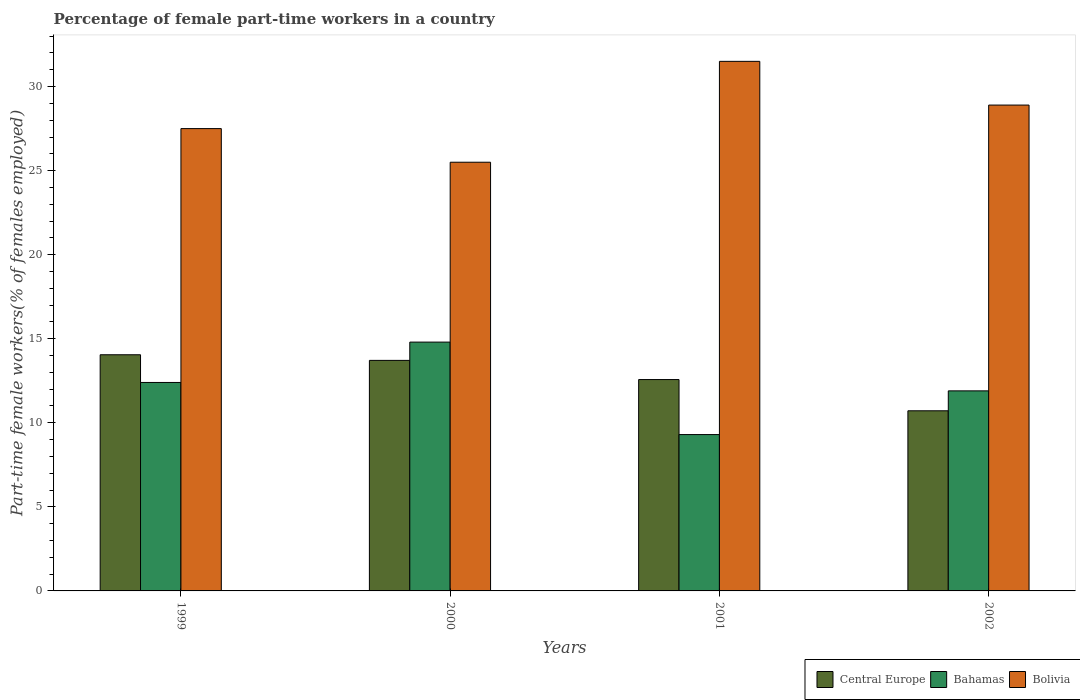How many groups of bars are there?
Make the answer very short. 4. Are the number of bars per tick equal to the number of legend labels?
Keep it short and to the point. Yes. How many bars are there on the 2nd tick from the left?
Your answer should be very brief. 3. How many bars are there on the 1st tick from the right?
Keep it short and to the point. 3. What is the label of the 2nd group of bars from the left?
Your answer should be very brief. 2000. In how many cases, is the number of bars for a given year not equal to the number of legend labels?
Ensure brevity in your answer.  0. Across all years, what is the maximum percentage of female part-time workers in Bolivia?
Your response must be concise. 31.5. Across all years, what is the minimum percentage of female part-time workers in Bahamas?
Provide a short and direct response. 9.3. What is the total percentage of female part-time workers in Bahamas in the graph?
Provide a succinct answer. 48.4. What is the difference between the percentage of female part-time workers in Central Europe in 2001 and that in 2002?
Provide a succinct answer. 1.86. What is the difference between the percentage of female part-time workers in Central Europe in 2002 and the percentage of female part-time workers in Bolivia in 1999?
Ensure brevity in your answer.  -16.79. What is the average percentage of female part-time workers in Central Europe per year?
Your answer should be very brief. 12.76. In the year 2002, what is the difference between the percentage of female part-time workers in Central Europe and percentage of female part-time workers in Bahamas?
Make the answer very short. -1.19. In how many years, is the percentage of female part-time workers in Bahamas greater than 7 %?
Your answer should be compact. 4. What is the ratio of the percentage of female part-time workers in Bahamas in 2000 to that in 2002?
Your response must be concise. 1.24. What is the difference between the highest and the second highest percentage of female part-time workers in Bolivia?
Give a very brief answer. 2.6. What is the difference between the highest and the lowest percentage of female part-time workers in Central Europe?
Your response must be concise. 3.33. Is the sum of the percentage of female part-time workers in Bahamas in 1999 and 2000 greater than the maximum percentage of female part-time workers in Central Europe across all years?
Offer a very short reply. Yes. What does the 2nd bar from the left in 2000 represents?
Provide a succinct answer. Bahamas. What does the 2nd bar from the right in 2001 represents?
Offer a terse response. Bahamas. Is it the case that in every year, the sum of the percentage of female part-time workers in Central Europe and percentage of female part-time workers in Bolivia is greater than the percentage of female part-time workers in Bahamas?
Make the answer very short. Yes. Are all the bars in the graph horizontal?
Provide a short and direct response. No. What is the difference between two consecutive major ticks on the Y-axis?
Keep it short and to the point. 5. Are the values on the major ticks of Y-axis written in scientific E-notation?
Provide a succinct answer. No. Does the graph contain any zero values?
Your answer should be compact. No. How are the legend labels stacked?
Make the answer very short. Horizontal. What is the title of the graph?
Your answer should be very brief. Percentage of female part-time workers in a country. Does "Faeroe Islands" appear as one of the legend labels in the graph?
Keep it short and to the point. No. What is the label or title of the Y-axis?
Offer a terse response. Part-time female workers(% of females employed). What is the Part-time female workers(% of females employed) in Central Europe in 1999?
Your response must be concise. 14.05. What is the Part-time female workers(% of females employed) in Bahamas in 1999?
Your response must be concise. 12.4. What is the Part-time female workers(% of females employed) of Bolivia in 1999?
Provide a succinct answer. 27.5. What is the Part-time female workers(% of females employed) in Central Europe in 2000?
Keep it short and to the point. 13.71. What is the Part-time female workers(% of females employed) in Bahamas in 2000?
Offer a terse response. 14.8. What is the Part-time female workers(% of females employed) in Central Europe in 2001?
Provide a succinct answer. 12.57. What is the Part-time female workers(% of females employed) of Bahamas in 2001?
Offer a very short reply. 9.3. What is the Part-time female workers(% of females employed) in Bolivia in 2001?
Make the answer very short. 31.5. What is the Part-time female workers(% of females employed) in Central Europe in 2002?
Your answer should be very brief. 10.71. What is the Part-time female workers(% of females employed) in Bahamas in 2002?
Give a very brief answer. 11.9. What is the Part-time female workers(% of females employed) of Bolivia in 2002?
Provide a short and direct response. 28.9. Across all years, what is the maximum Part-time female workers(% of females employed) of Central Europe?
Make the answer very short. 14.05. Across all years, what is the maximum Part-time female workers(% of females employed) in Bahamas?
Provide a short and direct response. 14.8. Across all years, what is the maximum Part-time female workers(% of females employed) in Bolivia?
Provide a succinct answer. 31.5. Across all years, what is the minimum Part-time female workers(% of females employed) in Central Europe?
Your response must be concise. 10.71. Across all years, what is the minimum Part-time female workers(% of females employed) in Bahamas?
Provide a succinct answer. 9.3. Across all years, what is the minimum Part-time female workers(% of females employed) of Bolivia?
Provide a short and direct response. 25.5. What is the total Part-time female workers(% of females employed) in Central Europe in the graph?
Your response must be concise. 51.05. What is the total Part-time female workers(% of females employed) of Bahamas in the graph?
Provide a short and direct response. 48.4. What is the total Part-time female workers(% of females employed) of Bolivia in the graph?
Provide a succinct answer. 113.4. What is the difference between the Part-time female workers(% of females employed) of Central Europe in 1999 and that in 2000?
Make the answer very short. 0.33. What is the difference between the Part-time female workers(% of females employed) in Bolivia in 1999 and that in 2000?
Your response must be concise. 2. What is the difference between the Part-time female workers(% of females employed) of Central Europe in 1999 and that in 2001?
Your answer should be very brief. 1.47. What is the difference between the Part-time female workers(% of females employed) in Bahamas in 1999 and that in 2001?
Your response must be concise. 3.1. What is the difference between the Part-time female workers(% of females employed) of Central Europe in 1999 and that in 2002?
Keep it short and to the point. 3.33. What is the difference between the Part-time female workers(% of females employed) of Bolivia in 1999 and that in 2002?
Ensure brevity in your answer.  -1.4. What is the difference between the Part-time female workers(% of females employed) in Central Europe in 2000 and that in 2001?
Offer a very short reply. 1.14. What is the difference between the Part-time female workers(% of females employed) of Central Europe in 2000 and that in 2002?
Your answer should be very brief. 3. What is the difference between the Part-time female workers(% of females employed) of Bahamas in 2000 and that in 2002?
Your answer should be compact. 2.9. What is the difference between the Part-time female workers(% of females employed) in Central Europe in 2001 and that in 2002?
Your response must be concise. 1.86. What is the difference between the Part-time female workers(% of females employed) in Central Europe in 1999 and the Part-time female workers(% of females employed) in Bahamas in 2000?
Offer a very short reply. -0.75. What is the difference between the Part-time female workers(% of females employed) of Central Europe in 1999 and the Part-time female workers(% of females employed) of Bolivia in 2000?
Offer a terse response. -11.45. What is the difference between the Part-time female workers(% of females employed) in Central Europe in 1999 and the Part-time female workers(% of females employed) in Bahamas in 2001?
Provide a succinct answer. 4.75. What is the difference between the Part-time female workers(% of females employed) of Central Europe in 1999 and the Part-time female workers(% of females employed) of Bolivia in 2001?
Ensure brevity in your answer.  -17.45. What is the difference between the Part-time female workers(% of females employed) of Bahamas in 1999 and the Part-time female workers(% of females employed) of Bolivia in 2001?
Make the answer very short. -19.1. What is the difference between the Part-time female workers(% of females employed) in Central Europe in 1999 and the Part-time female workers(% of females employed) in Bahamas in 2002?
Your answer should be compact. 2.15. What is the difference between the Part-time female workers(% of females employed) in Central Europe in 1999 and the Part-time female workers(% of females employed) in Bolivia in 2002?
Your answer should be very brief. -14.85. What is the difference between the Part-time female workers(% of females employed) of Bahamas in 1999 and the Part-time female workers(% of females employed) of Bolivia in 2002?
Provide a short and direct response. -16.5. What is the difference between the Part-time female workers(% of females employed) of Central Europe in 2000 and the Part-time female workers(% of females employed) of Bahamas in 2001?
Give a very brief answer. 4.41. What is the difference between the Part-time female workers(% of females employed) of Central Europe in 2000 and the Part-time female workers(% of females employed) of Bolivia in 2001?
Your answer should be very brief. -17.79. What is the difference between the Part-time female workers(% of females employed) of Bahamas in 2000 and the Part-time female workers(% of females employed) of Bolivia in 2001?
Keep it short and to the point. -16.7. What is the difference between the Part-time female workers(% of females employed) in Central Europe in 2000 and the Part-time female workers(% of females employed) in Bahamas in 2002?
Keep it short and to the point. 1.81. What is the difference between the Part-time female workers(% of females employed) in Central Europe in 2000 and the Part-time female workers(% of females employed) in Bolivia in 2002?
Your response must be concise. -15.19. What is the difference between the Part-time female workers(% of females employed) in Bahamas in 2000 and the Part-time female workers(% of females employed) in Bolivia in 2002?
Your answer should be compact. -14.1. What is the difference between the Part-time female workers(% of females employed) of Central Europe in 2001 and the Part-time female workers(% of females employed) of Bahamas in 2002?
Offer a terse response. 0.67. What is the difference between the Part-time female workers(% of females employed) of Central Europe in 2001 and the Part-time female workers(% of females employed) of Bolivia in 2002?
Give a very brief answer. -16.33. What is the difference between the Part-time female workers(% of females employed) in Bahamas in 2001 and the Part-time female workers(% of females employed) in Bolivia in 2002?
Make the answer very short. -19.6. What is the average Part-time female workers(% of females employed) of Central Europe per year?
Your answer should be very brief. 12.76. What is the average Part-time female workers(% of females employed) of Bolivia per year?
Your response must be concise. 28.35. In the year 1999, what is the difference between the Part-time female workers(% of females employed) of Central Europe and Part-time female workers(% of females employed) of Bahamas?
Ensure brevity in your answer.  1.65. In the year 1999, what is the difference between the Part-time female workers(% of females employed) in Central Europe and Part-time female workers(% of females employed) in Bolivia?
Offer a very short reply. -13.45. In the year 1999, what is the difference between the Part-time female workers(% of females employed) in Bahamas and Part-time female workers(% of females employed) in Bolivia?
Offer a very short reply. -15.1. In the year 2000, what is the difference between the Part-time female workers(% of females employed) in Central Europe and Part-time female workers(% of females employed) in Bahamas?
Give a very brief answer. -1.09. In the year 2000, what is the difference between the Part-time female workers(% of females employed) of Central Europe and Part-time female workers(% of females employed) of Bolivia?
Offer a very short reply. -11.79. In the year 2000, what is the difference between the Part-time female workers(% of females employed) in Bahamas and Part-time female workers(% of females employed) in Bolivia?
Ensure brevity in your answer.  -10.7. In the year 2001, what is the difference between the Part-time female workers(% of females employed) of Central Europe and Part-time female workers(% of females employed) of Bahamas?
Your answer should be compact. 3.27. In the year 2001, what is the difference between the Part-time female workers(% of females employed) in Central Europe and Part-time female workers(% of females employed) in Bolivia?
Offer a very short reply. -18.93. In the year 2001, what is the difference between the Part-time female workers(% of females employed) in Bahamas and Part-time female workers(% of females employed) in Bolivia?
Your answer should be compact. -22.2. In the year 2002, what is the difference between the Part-time female workers(% of females employed) in Central Europe and Part-time female workers(% of females employed) in Bahamas?
Your answer should be very brief. -1.19. In the year 2002, what is the difference between the Part-time female workers(% of females employed) of Central Europe and Part-time female workers(% of females employed) of Bolivia?
Your response must be concise. -18.19. What is the ratio of the Part-time female workers(% of females employed) in Central Europe in 1999 to that in 2000?
Ensure brevity in your answer.  1.02. What is the ratio of the Part-time female workers(% of females employed) of Bahamas in 1999 to that in 2000?
Offer a very short reply. 0.84. What is the ratio of the Part-time female workers(% of females employed) of Bolivia in 1999 to that in 2000?
Your response must be concise. 1.08. What is the ratio of the Part-time female workers(% of females employed) in Central Europe in 1999 to that in 2001?
Ensure brevity in your answer.  1.12. What is the ratio of the Part-time female workers(% of females employed) of Bahamas in 1999 to that in 2001?
Make the answer very short. 1.33. What is the ratio of the Part-time female workers(% of females employed) in Bolivia in 1999 to that in 2001?
Keep it short and to the point. 0.87. What is the ratio of the Part-time female workers(% of females employed) in Central Europe in 1999 to that in 2002?
Offer a very short reply. 1.31. What is the ratio of the Part-time female workers(% of females employed) of Bahamas in 1999 to that in 2002?
Provide a short and direct response. 1.04. What is the ratio of the Part-time female workers(% of females employed) of Bolivia in 1999 to that in 2002?
Your response must be concise. 0.95. What is the ratio of the Part-time female workers(% of females employed) in Central Europe in 2000 to that in 2001?
Your answer should be compact. 1.09. What is the ratio of the Part-time female workers(% of females employed) of Bahamas in 2000 to that in 2001?
Provide a succinct answer. 1.59. What is the ratio of the Part-time female workers(% of females employed) of Bolivia in 2000 to that in 2001?
Offer a terse response. 0.81. What is the ratio of the Part-time female workers(% of females employed) of Central Europe in 2000 to that in 2002?
Ensure brevity in your answer.  1.28. What is the ratio of the Part-time female workers(% of females employed) of Bahamas in 2000 to that in 2002?
Your answer should be compact. 1.24. What is the ratio of the Part-time female workers(% of females employed) in Bolivia in 2000 to that in 2002?
Your answer should be compact. 0.88. What is the ratio of the Part-time female workers(% of females employed) in Central Europe in 2001 to that in 2002?
Ensure brevity in your answer.  1.17. What is the ratio of the Part-time female workers(% of females employed) of Bahamas in 2001 to that in 2002?
Offer a terse response. 0.78. What is the ratio of the Part-time female workers(% of females employed) of Bolivia in 2001 to that in 2002?
Ensure brevity in your answer.  1.09. What is the difference between the highest and the second highest Part-time female workers(% of females employed) in Central Europe?
Your answer should be very brief. 0.33. What is the difference between the highest and the second highest Part-time female workers(% of females employed) of Bahamas?
Offer a terse response. 2.4. What is the difference between the highest and the lowest Part-time female workers(% of females employed) in Central Europe?
Your answer should be compact. 3.33. 